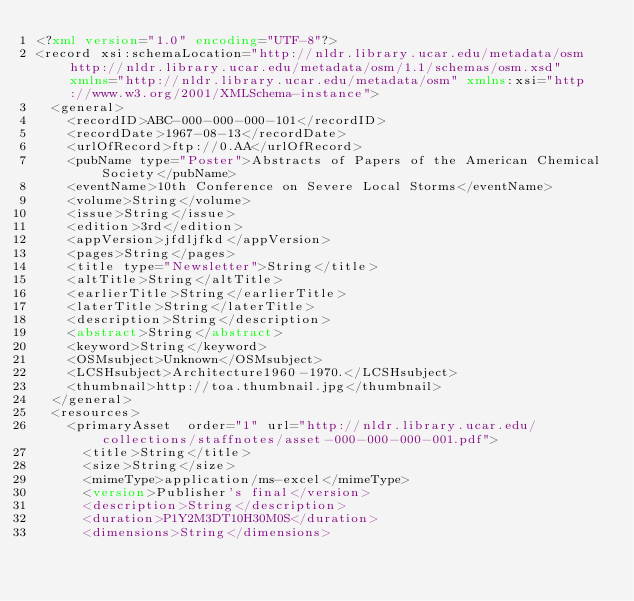Convert code to text. <code><loc_0><loc_0><loc_500><loc_500><_XML_><?xml version="1.0" encoding="UTF-8"?>
<record xsi:schemaLocation="http://nldr.library.ucar.edu/metadata/osm http://nldr.library.ucar.edu/metadata/osm/1.1/schemas/osm.xsd" xmlns="http://nldr.library.ucar.edu/metadata/osm" xmlns:xsi="http://www.w3.org/2001/XMLSchema-instance">
	<general>
		<recordID>ABC-000-000-000-101</recordID>
		<recordDate>1967-08-13</recordDate>
		<urlOfRecord>ftp://0.AA</urlOfRecord>
		<pubName type="Poster">Abstracts of Papers of the American Chemical Society</pubName>
		<eventName>10th Conference on Severe Local Storms</eventName>
		<volume>String</volume>
		<issue>String</issue>
		<edition>3rd</edition>
		<appVersion>jfdljfkd</appVersion>
		<pages>String</pages>
		<title type="Newsletter">String</title>
		<altTitle>String</altTitle>
		<earlierTitle>String</earlierTitle>
		<laterTitle>String</laterTitle>
		<description>String</description>
		<abstract>String</abstract>
		<keyword>String</keyword>
		<OSMsubject>Unknown</OSMsubject>
		<LCSHsubject>Architecture1960-1970.</LCSHsubject>
		<thumbnail>http://toa.thumbnail.jpg</thumbnail>
	</general>
	<resources>
		<primaryAsset  order="1" url="http://nldr.library.ucar.edu/collections/staffnotes/asset-000-000-000-001.pdf">
			<title>String</title>
			<size>String</size>
			<mimeType>application/ms-excel</mimeType>
			<version>Publisher's final</version>
			<description>String</description>
			<duration>P1Y2M3DT10H30M0S</duration>
			<dimensions>String</dimensions></code> 